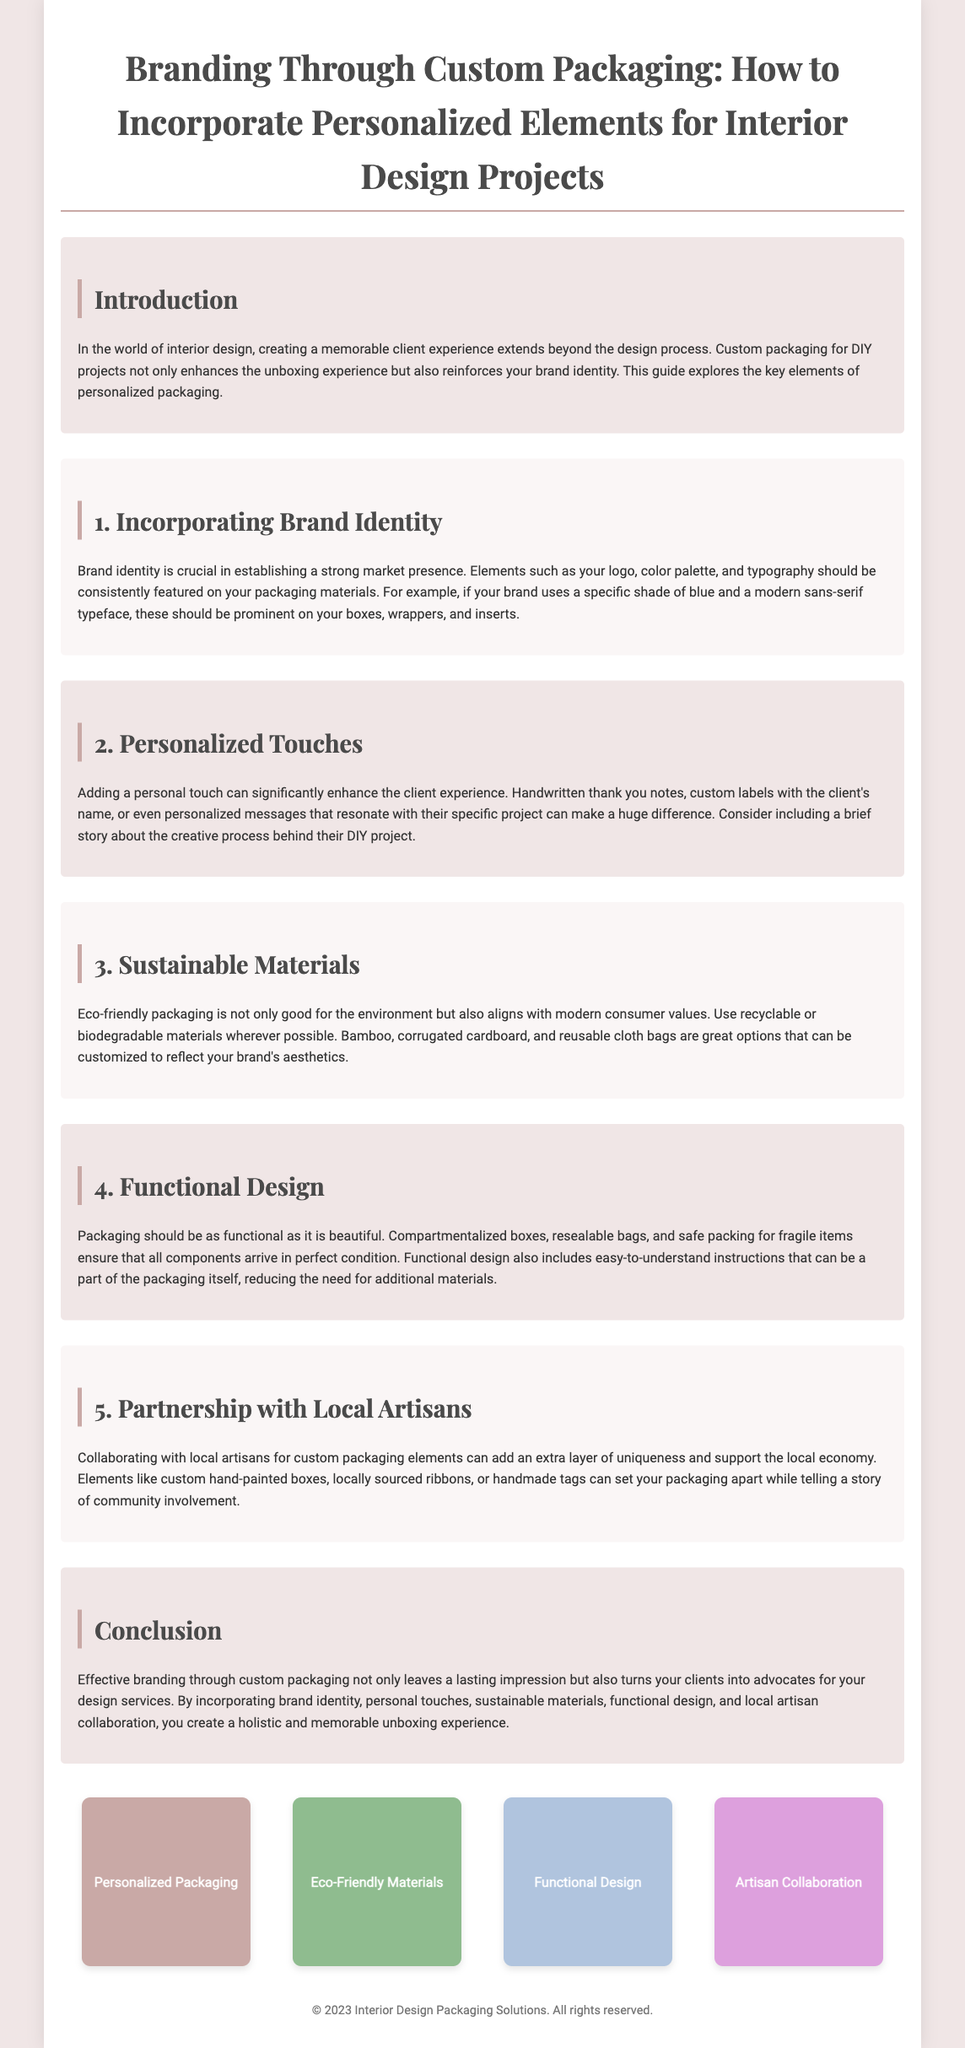What is the title of the document? The title can be found at the top of the document, which is a key element indicating the main topic.
Answer: Branding Through Custom Packaging: How to Incorporate Personalized Elements for Interior Design Projects What are some examples of sustainable materials mentioned? The document lists eco-friendly materials as part of its discussion on packaging, highlighting materials that align with modern consumer values.
Answer: Recyclable or biodegradable materials What is a personalized touch mentioned that can enhance client experience? The document provides specific examples of personal touches that can be included in packaging to improve the customer experience.
Answer: Handwritten thank you notes Which section discusses the importance of brand identity? Each section is clearly labeled, and the headings provide direct cues about the content discussed, with one specifically focusing on brand identity.
Answer: Incorporating Brand Identity What is one benefit of collaborating with local artisans? The document mentions the advantages of working with local artisans, which supports community engagement and adds uniqueness to packaging.
Answer: Support the local economy What should functional packaging ensure? The document outlines specific design characteristics packaging should have to be effective, emphasizing functionality in its presentation.
Answer: All components arrive in perfect condition How many sections are listed in the document? The document structurally divides content into distinct segments, each addressing a different aspect of custom packaging for interior design.
Answer: Five sections What color palette is suggested for packaging design? The document does not provide a specific color but implies the need for a consistent color palette related to brand identity, indicating the importance of coherent branding.
Answer: Specific shade of blue How does custom packaging benefit your brand? The document explains the main advantages of utilizing customized packaging and the effects it can have on customer perception and loyalty.
Answer: Leaves a lasting impression 